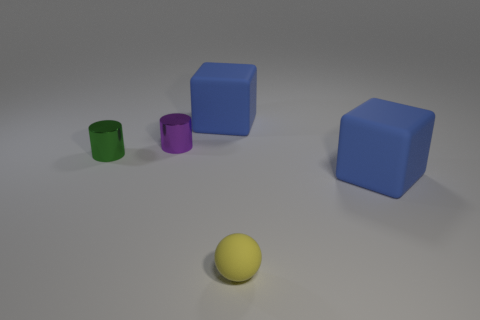There is a tiny metallic cylinder that is right of the shiny thing left of the purple shiny object; is there a large object that is left of it?
Your answer should be compact. No. There is a green thing that is the same shape as the purple metallic thing; what material is it?
Give a very brief answer. Metal. There is a large matte block behind the green shiny thing; what color is it?
Provide a short and direct response. Blue. There is a yellow matte ball; is its size the same as the blue rubber thing in front of the green shiny cylinder?
Your answer should be very brief. No. What color is the large rubber cube on the left side of the large rubber object that is in front of the blue matte object that is to the left of the rubber ball?
Keep it short and to the point. Blue. Are the cylinder on the right side of the green object and the sphere made of the same material?
Provide a succinct answer. No. There is a yellow object that is the same size as the purple object; what material is it?
Ensure brevity in your answer.  Rubber. Is the shape of the tiny object that is to the right of the purple metallic cylinder the same as the big thing that is in front of the purple metallic object?
Your response must be concise. No. The yellow matte object that is the same size as the green cylinder is what shape?
Provide a short and direct response. Sphere. Does the tiny cylinder in front of the purple cylinder have the same material as the tiny object behind the tiny green shiny cylinder?
Provide a short and direct response. Yes. 